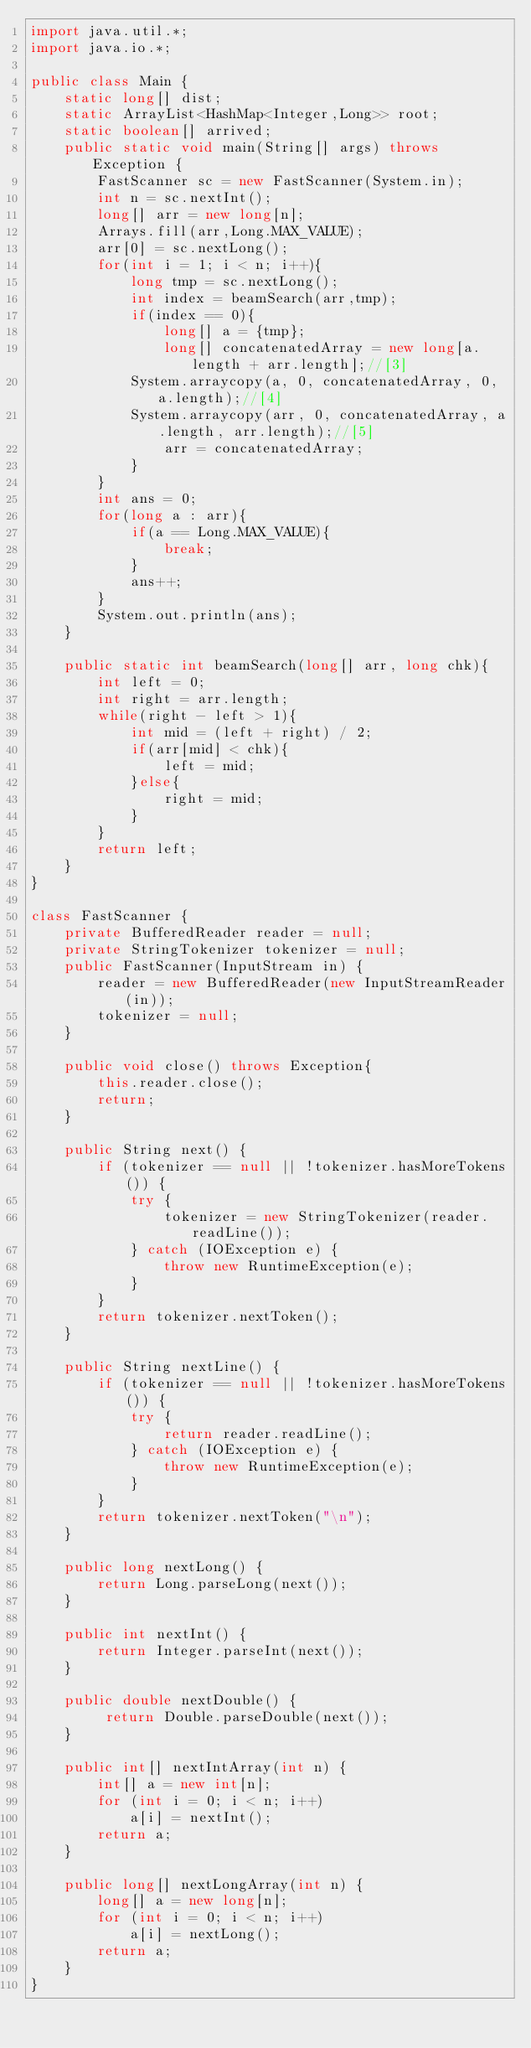Convert code to text. <code><loc_0><loc_0><loc_500><loc_500><_Java_>import java.util.*;
import java.io.*;
 
public class Main {
    static long[] dist;
    static ArrayList<HashMap<Integer,Long>> root;
    static boolean[] arrived;
    public static void main(String[] args) throws Exception {
        FastScanner sc = new FastScanner(System.in);
        int n = sc.nextInt();
        long[] arr = new long[n];
        Arrays.fill(arr,Long.MAX_VALUE);
        arr[0] = sc.nextLong();
        for(int i = 1; i < n; i++){
            long tmp = sc.nextLong();
            int index = beamSearch(arr,tmp);
            if(index == 0){
                long[] a = {tmp};
                long[] concatenatedArray = new long[a.length + arr.length];//[3]
        		System.arraycopy(a, 0, concatenatedArray, 0, a.length);//[4]
        		System.arraycopy(arr, 0, concatenatedArray, a.length, arr.length);//[5]
                arr = concatenatedArray;
            }
        }
        int ans = 0;
        for(long a : arr){
            if(a == Long.MAX_VALUE){
                break;
            }
            ans++;
        }
        System.out.println(ans);
    }
    
    public static int beamSearch(long[] arr, long chk){
        int left = 0;
        int right = arr.length;
        while(right - left > 1){
            int mid = (left + right) / 2;
            if(arr[mid] < chk){
                left = mid;
            }else{
                right = mid;
            }
        }
        return left;
    }
}

class FastScanner {
    private BufferedReader reader = null;
    private StringTokenizer tokenizer = null;
    public FastScanner(InputStream in) {
        reader = new BufferedReader(new InputStreamReader(in));
        tokenizer = null;
    }
    
    public void close() throws Exception{
        this.reader.close();
        return;
    }

    public String next() {
        if (tokenizer == null || !tokenizer.hasMoreTokens()) {
            try {
                tokenizer = new StringTokenizer(reader.readLine());
            } catch (IOException e) {
                throw new RuntimeException(e);
            }
        }
        return tokenizer.nextToken();
    }

    public String nextLine() {
        if (tokenizer == null || !tokenizer.hasMoreTokens()) {
            try {
                return reader.readLine();
            } catch (IOException e) {
                throw new RuntimeException(e);
            }
        }
        return tokenizer.nextToken("\n");
    }

    public long nextLong() {
        return Long.parseLong(next());
    }

    public int nextInt() {
        return Integer.parseInt(next());
    }

    public double nextDouble() {
         return Double.parseDouble(next());
    }

    public int[] nextIntArray(int n) {
        int[] a = new int[n];
        for (int i = 0; i < n; i++)
            a[i] = nextInt();
        return a;
    }

    public long[] nextLongArray(int n) {
        long[] a = new long[n];
        for (int i = 0; i < n; i++)
            a[i] = nextLong();
        return a;
    } 
}</code> 